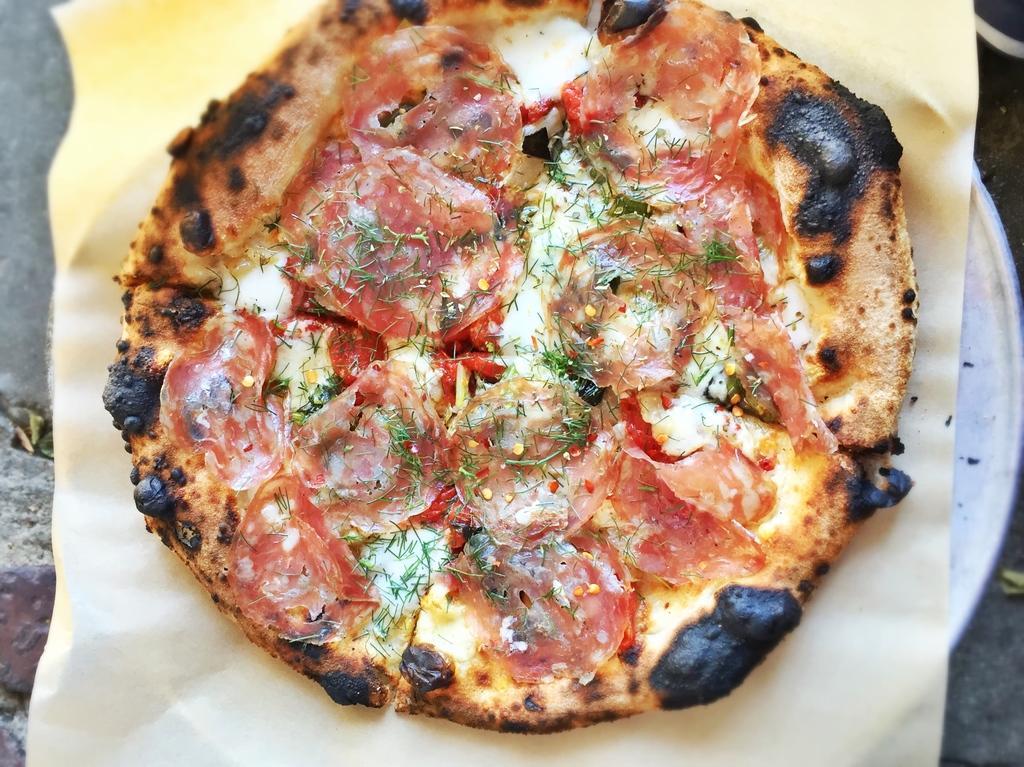Can you describe this image briefly? In this picture, it seems like a pizza on a tissue. 